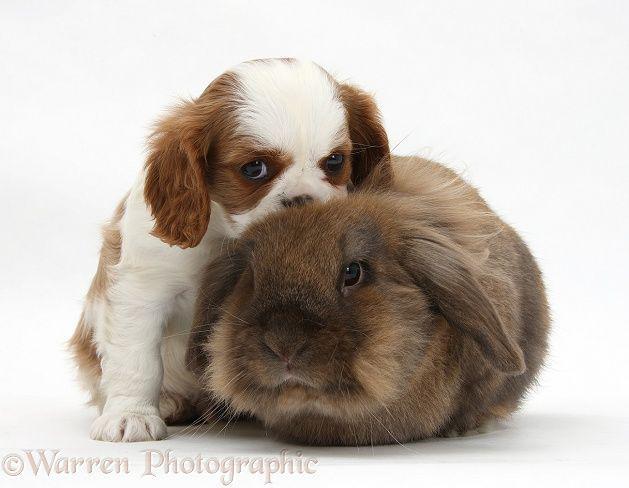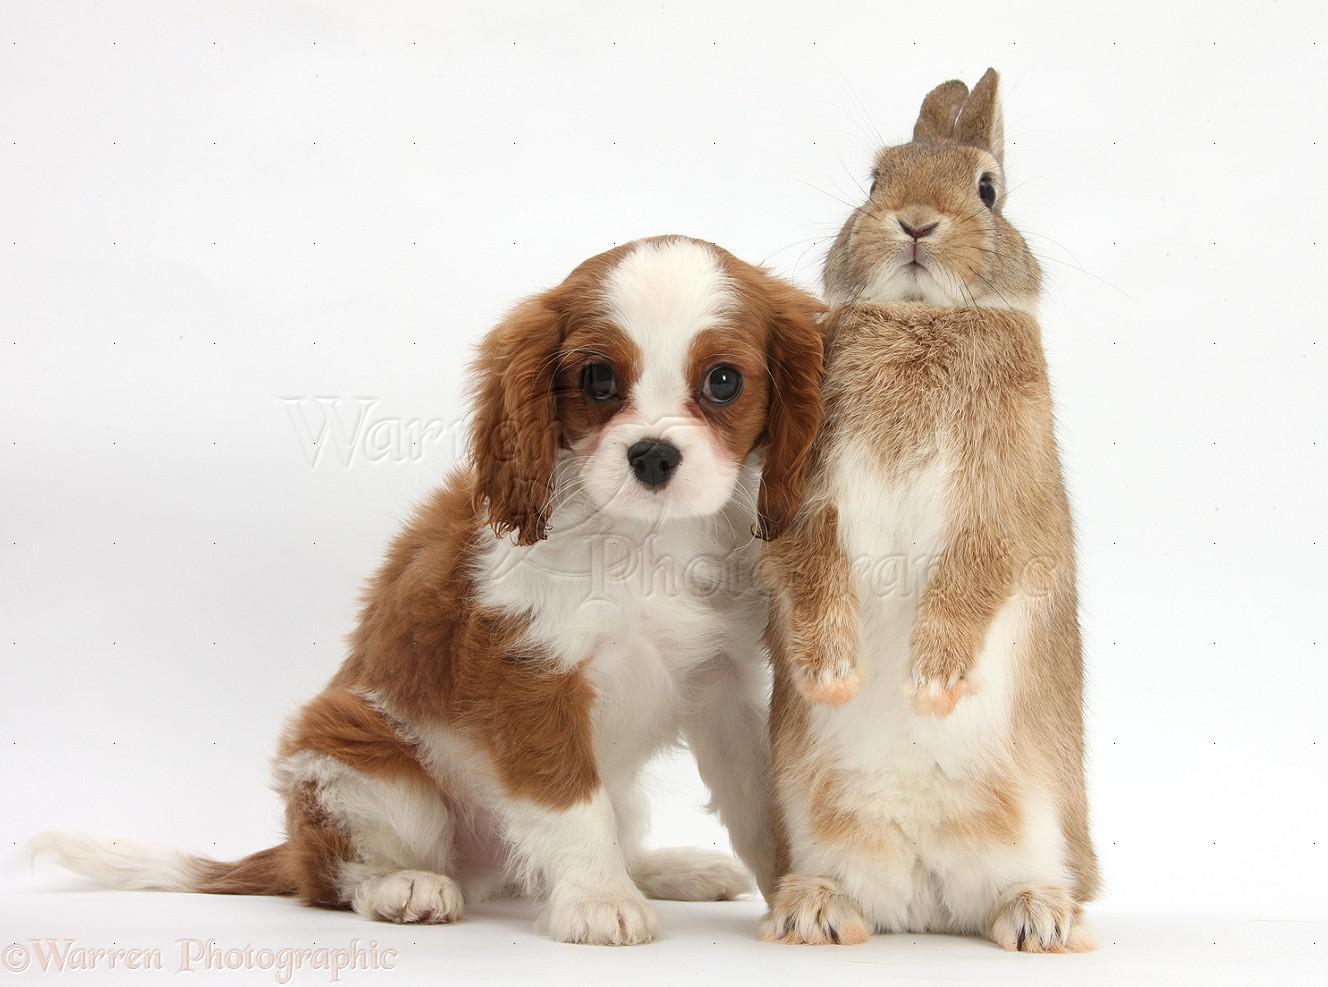The first image is the image on the left, the second image is the image on the right. Evaluate the accuracy of this statement regarding the images: "A rabbit is between two puppies in one image.". Is it true? Answer yes or no. No. The first image is the image on the left, the second image is the image on the right. Given the left and right images, does the statement "In one of the images, a brown rabbit is in between two white and brown cocker spaniel puppies" hold true? Answer yes or no. No. 